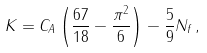Convert formula to latex. <formula><loc_0><loc_0><loc_500><loc_500>K = C _ { A } \left ( \frac { 6 7 } { 1 8 } - \frac { \pi ^ { 2 } } { 6 } \right ) - \frac { 5 } { 9 } N _ { f } \, ,</formula> 